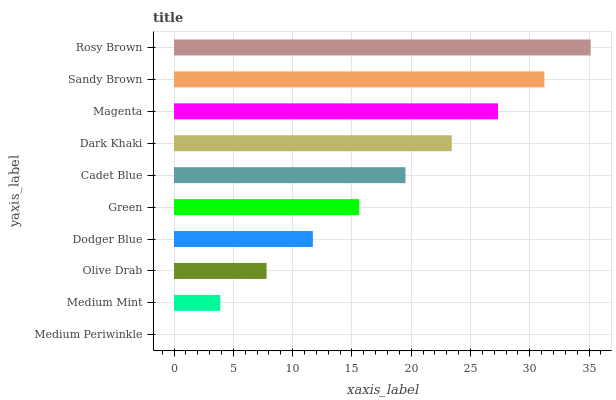Is Medium Periwinkle the minimum?
Answer yes or no. Yes. Is Rosy Brown the maximum?
Answer yes or no. Yes. Is Medium Mint the minimum?
Answer yes or no. No. Is Medium Mint the maximum?
Answer yes or no. No. Is Medium Mint greater than Medium Periwinkle?
Answer yes or no. Yes. Is Medium Periwinkle less than Medium Mint?
Answer yes or no. Yes. Is Medium Periwinkle greater than Medium Mint?
Answer yes or no. No. Is Medium Mint less than Medium Periwinkle?
Answer yes or no. No. Is Cadet Blue the high median?
Answer yes or no. Yes. Is Green the low median?
Answer yes or no. Yes. Is Magenta the high median?
Answer yes or no. No. Is Sandy Brown the low median?
Answer yes or no. No. 